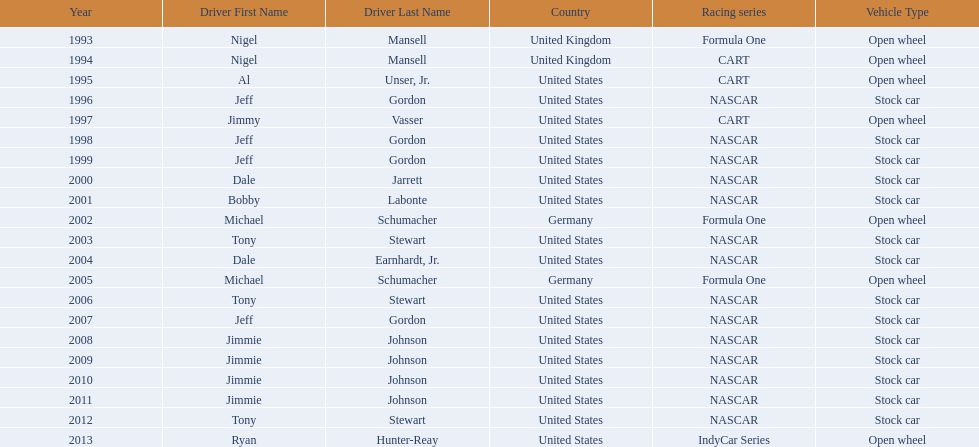What year(s) did nigel mansel receive epsy awards? 1993, 1994. What year(s) did michael schumacher receive epsy awards? 2002, 2005. What year(s) did jeff gordon receive epsy awards? 1996, 1998, 1999, 2007. What year(s) did al unser jr. receive epsy awards? 1995. Which driver only received one epsy award? Al Unser, Jr. 